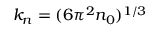Convert formula to latex. <formula><loc_0><loc_0><loc_500><loc_500>k _ { n } = ( 6 \pi ^ { 2 } n _ { 0 } ) ^ { 1 / 3 }</formula> 